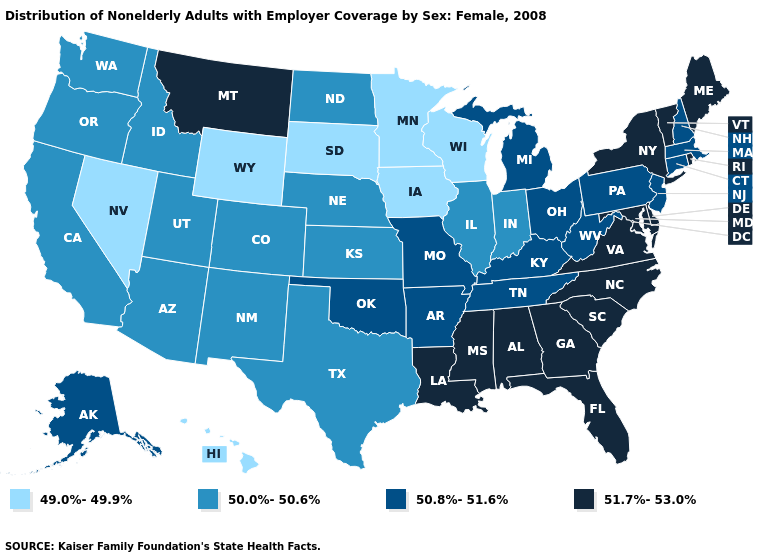Does Wisconsin have the lowest value in the MidWest?
Quick response, please. Yes. What is the lowest value in states that border Texas?
Answer briefly. 50.0%-50.6%. Does Louisiana have a lower value than Connecticut?
Quick response, please. No. Which states hav the highest value in the Northeast?
Quick response, please. Maine, New York, Rhode Island, Vermont. Among the states that border Illinois , which have the highest value?
Give a very brief answer. Kentucky, Missouri. Among the states that border California , does Nevada have the lowest value?
Concise answer only. Yes. Name the states that have a value in the range 49.0%-49.9%?
Be succinct. Hawaii, Iowa, Minnesota, Nevada, South Dakota, Wisconsin, Wyoming. What is the highest value in the Northeast ?
Answer briefly. 51.7%-53.0%. What is the value of Washington?
Write a very short answer. 50.0%-50.6%. What is the lowest value in the USA?
Write a very short answer. 49.0%-49.9%. What is the value of South Carolina?
Keep it brief. 51.7%-53.0%. Among the states that border Georgia , which have the lowest value?
Quick response, please. Tennessee. Which states have the lowest value in the MidWest?
Keep it brief. Iowa, Minnesota, South Dakota, Wisconsin. Is the legend a continuous bar?
Answer briefly. No. 